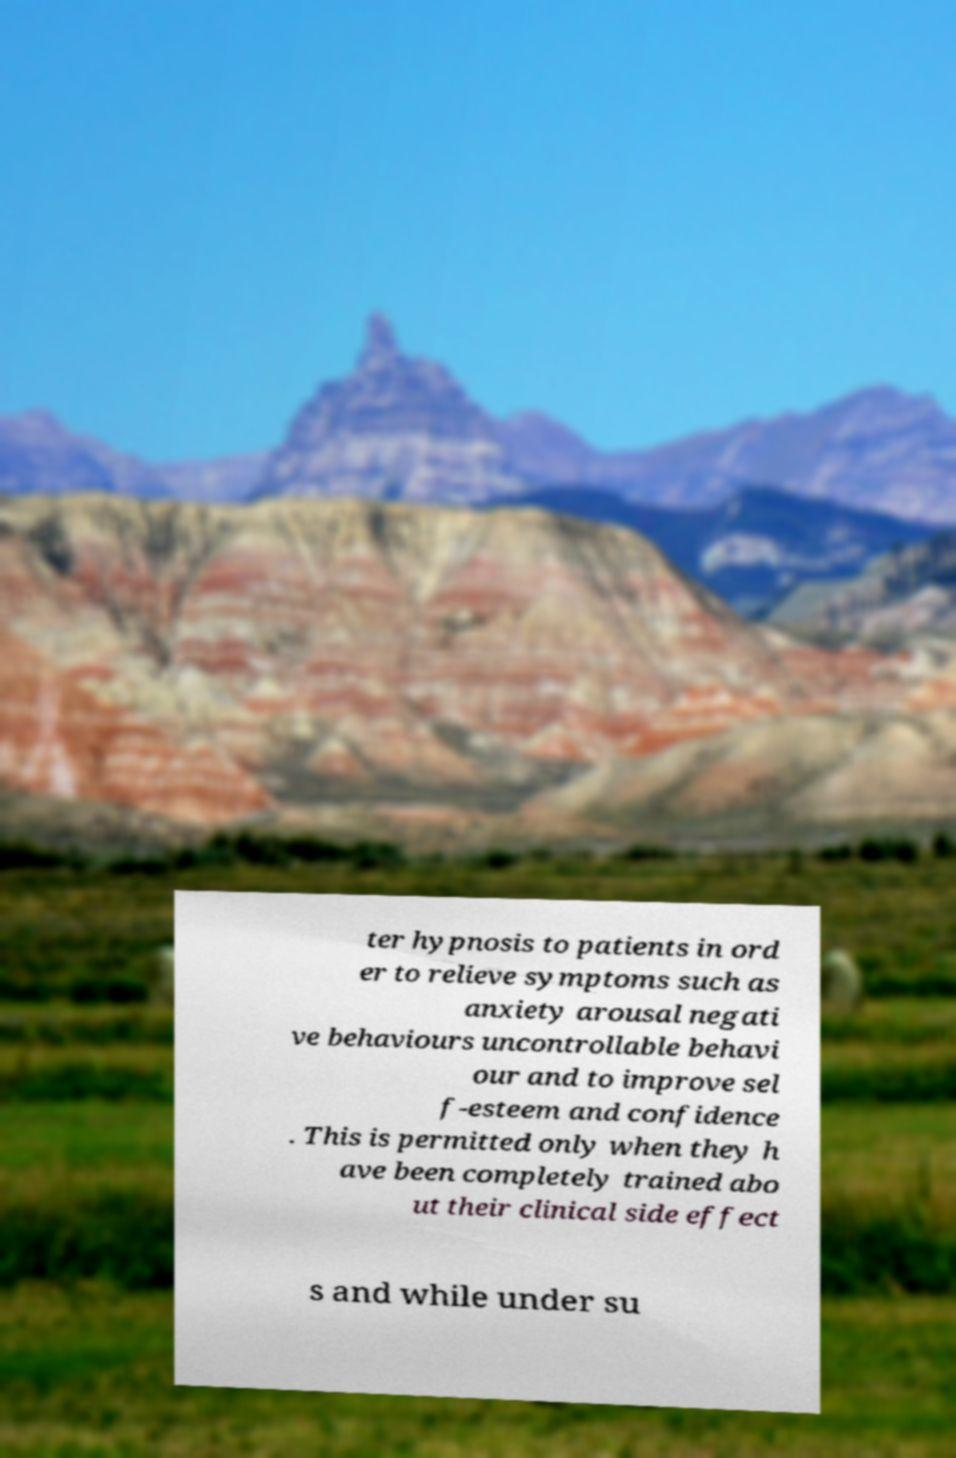For documentation purposes, I need the text within this image transcribed. Could you provide that? ter hypnosis to patients in ord er to relieve symptoms such as anxiety arousal negati ve behaviours uncontrollable behavi our and to improve sel f-esteem and confidence . This is permitted only when they h ave been completely trained abo ut their clinical side effect s and while under su 